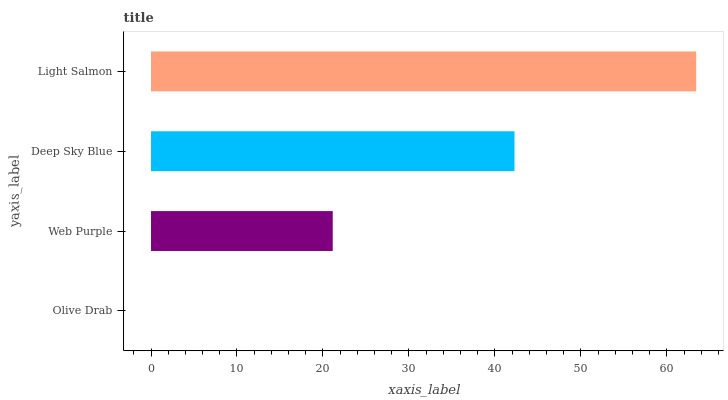Is Olive Drab the minimum?
Answer yes or no. Yes. Is Light Salmon the maximum?
Answer yes or no. Yes. Is Web Purple the minimum?
Answer yes or no. No. Is Web Purple the maximum?
Answer yes or no. No. Is Web Purple greater than Olive Drab?
Answer yes or no. Yes. Is Olive Drab less than Web Purple?
Answer yes or no. Yes. Is Olive Drab greater than Web Purple?
Answer yes or no. No. Is Web Purple less than Olive Drab?
Answer yes or no. No. Is Deep Sky Blue the high median?
Answer yes or no. Yes. Is Web Purple the low median?
Answer yes or no. Yes. Is Olive Drab the high median?
Answer yes or no. No. Is Light Salmon the low median?
Answer yes or no. No. 